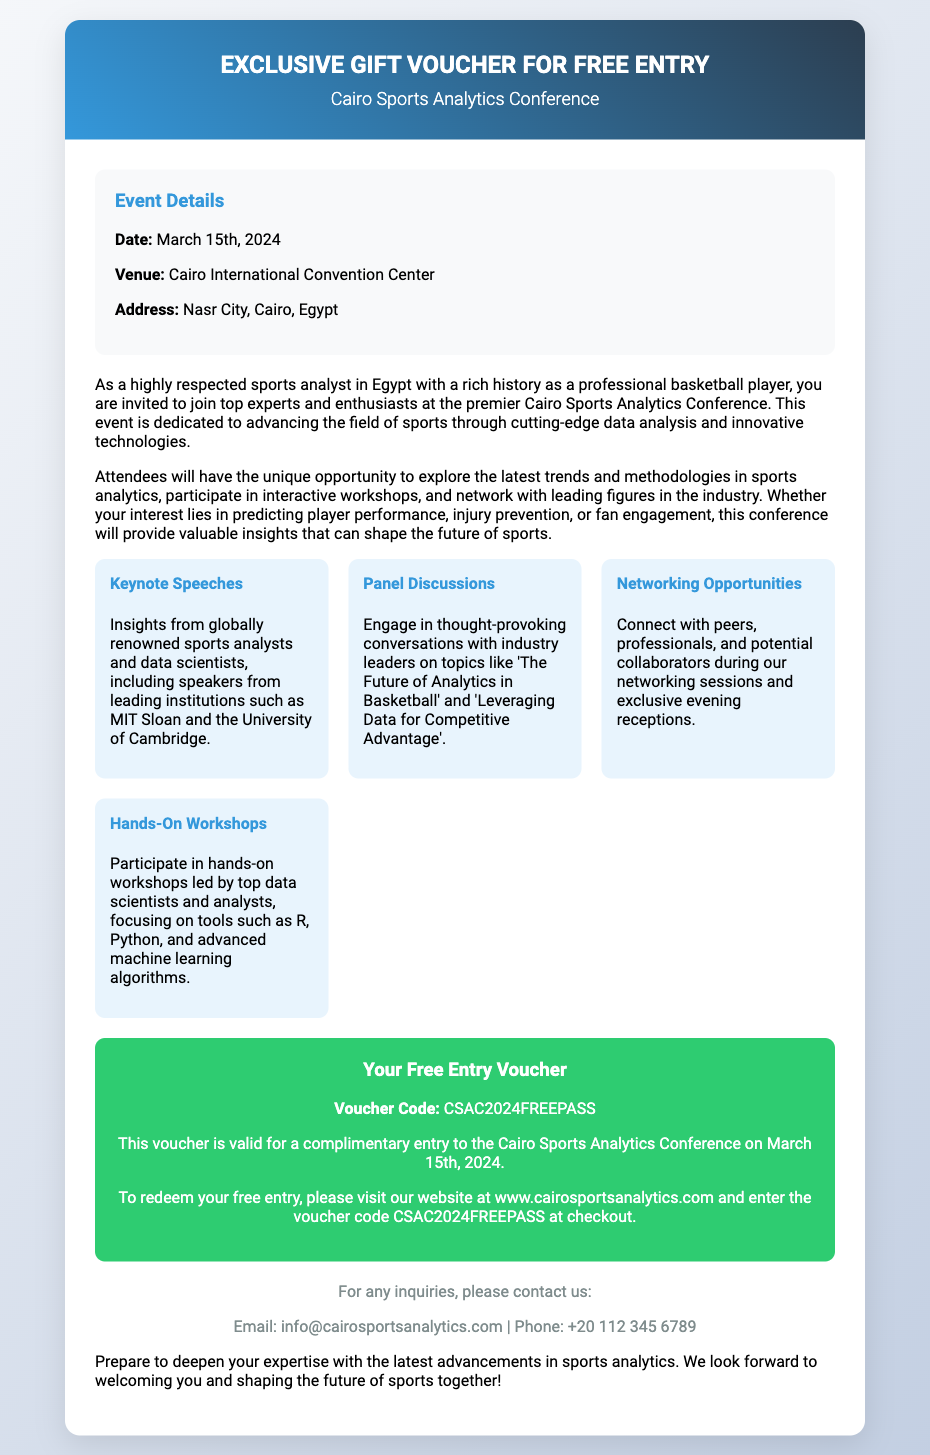What is the date of the conference? The date is specified in the document as March 15th, 2024.
Answer: March 15th, 2024 Where is the venue located? The venue's location is mentioned as Cairo International Convention Center, Nasr City, Cairo, Egypt.
Answer: Cairo International Convention Center What is the voucher code for free entry? The voucher code is presented in the registration section of the document as CSAC2024FREEPASS.
Answer: CSAC2024FREEPASS What type of opportunities are provided at the conference? The document lists networking opportunities as a key aspect of the conference.
Answer: Networking Opportunities Who are some of the keynote speakers associated with the conference? The document mentions speakers from globally renowned institutions such as MIT Sloan and the University of Cambridge as keynote speakers.
Answer: MIT Sloan and University of Cambridge What is the main purpose of the conference? The document states that the main purpose is to advance the field of sports through cutting-edge data analysis and innovative technologies.
Answer: Advance sports analytics How can attendees redeem their free entry? The document explains that attendees must visit the website and enter the voucher code at checkout.
Answer: Visit website What type of workshops will be available? The document highlights that there will be hands-on workshops led by top data scientists and analysts.
Answer: Hands-On Workshops What is the email contact for inquiries? The document provides the contact email as info@cairosportsanalytics.com.
Answer: info@cairosportsanalytics.com What color is the header background? The header background color is described as a gradient of blue and dark blue.
Answer: Blue gradient 